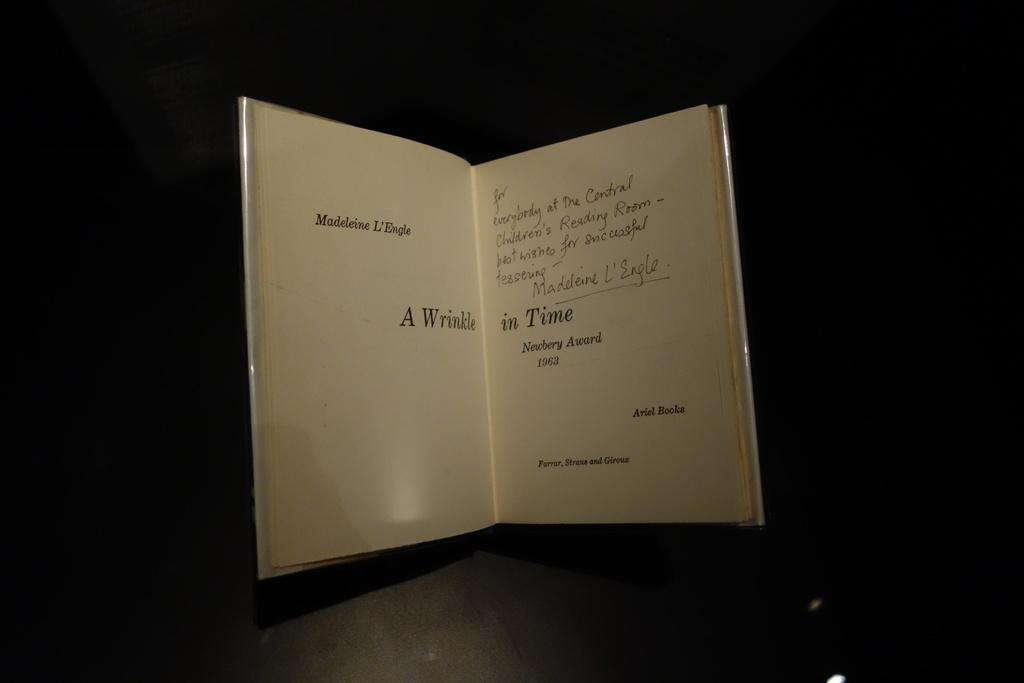Provide a one-sentence caption for the provided image. A signed book to the people at the Central Children's Reading Room. 